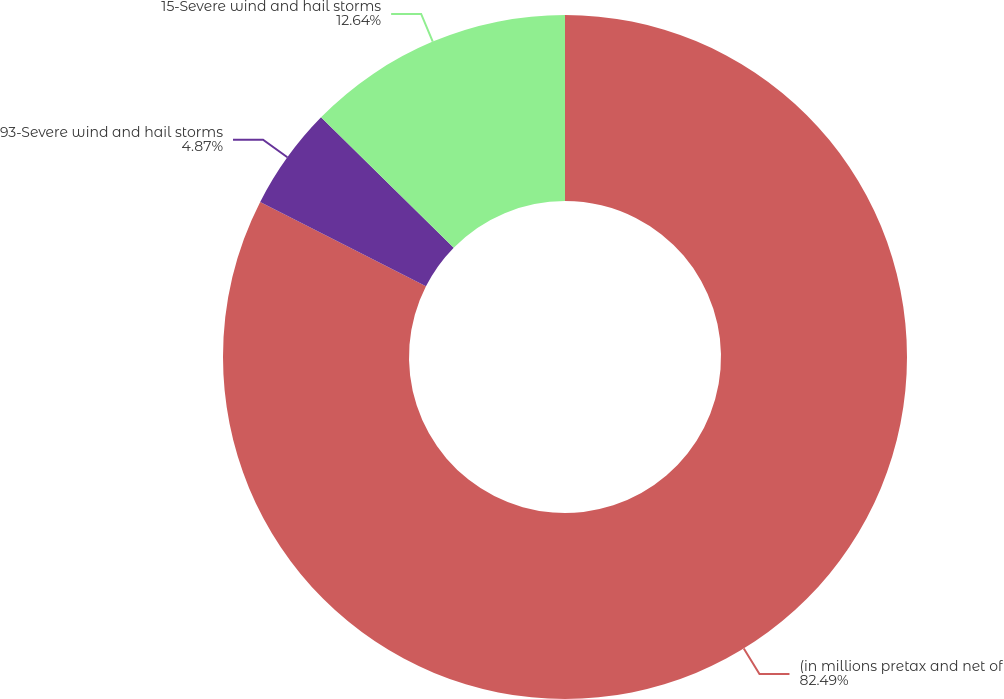<chart> <loc_0><loc_0><loc_500><loc_500><pie_chart><fcel>(in millions pretax and net of<fcel>93-Severe wind and hail storms<fcel>15-Severe wind and hail storms<nl><fcel>82.49%<fcel>4.87%<fcel>12.64%<nl></chart> 